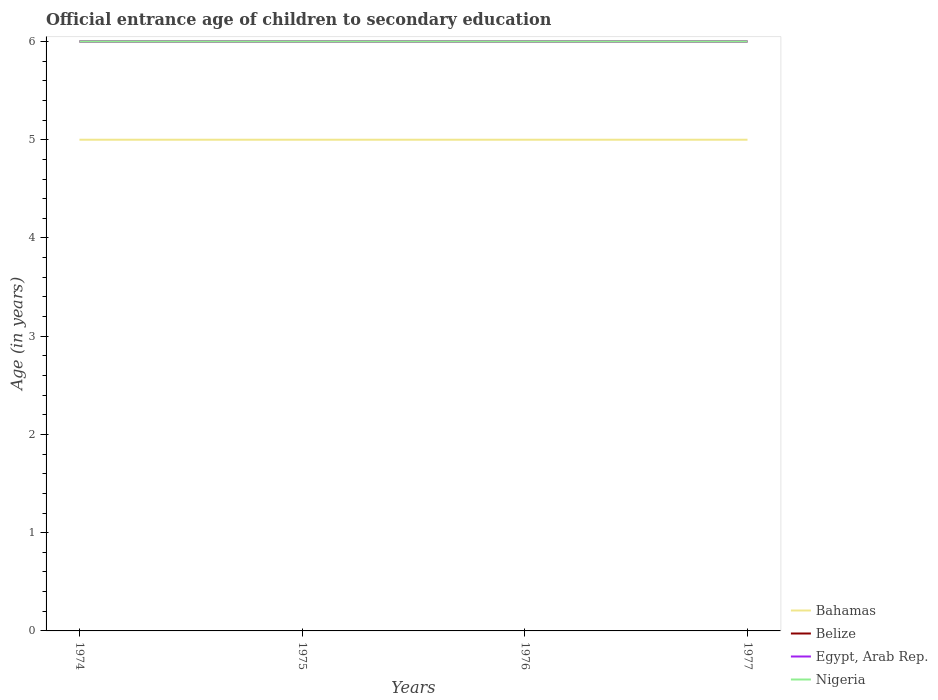How many different coloured lines are there?
Your response must be concise. 4. Does the line corresponding to Bahamas intersect with the line corresponding to Nigeria?
Offer a very short reply. No. Is the number of lines equal to the number of legend labels?
Your answer should be compact. Yes. Across all years, what is the maximum secondary school starting age of children in Bahamas?
Make the answer very short. 5. In which year was the secondary school starting age of children in Egypt, Arab Rep. maximum?
Give a very brief answer. 1974. What is the difference between the highest and the lowest secondary school starting age of children in Bahamas?
Your response must be concise. 0. Is the secondary school starting age of children in Bahamas strictly greater than the secondary school starting age of children in Egypt, Arab Rep. over the years?
Give a very brief answer. Yes. What is the difference between two consecutive major ticks on the Y-axis?
Your response must be concise. 1. Does the graph contain grids?
Your answer should be very brief. No. What is the title of the graph?
Make the answer very short. Official entrance age of children to secondary education. What is the label or title of the X-axis?
Ensure brevity in your answer.  Years. What is the label or title of the Y-axis?
Keep it short and to the point. Age (in years). What is the Age (in years) of Belize in 1974?
Ensure brevity in your answer.  6. What is the Age (in years) of Egypt, Arab Rep. in 1974?
Ensure brevity in your answer.  6. What is the Age (in years) of Egypt, Arab Rep. in 1975?
Offer a terse response. 6. What is the Age (in years) in Nigeria in 1975?
Give a very brief answer. 6. What is the Age (in years) of Bahamas in 1976?
Provide a short and direct response. 5. What is the Age (in years) in Nigeria in 1976?
Ensure brevity in your answer.  6. What is the Age (in years) of Egypt, Arab Rep. in 1977?
Give a very brief answer. 6. Across all years, what is the maximum Age (in years) of Belize?
Offer a very short reply. 6. Across all years, what is the maximum Age (in years) in Nigeria?
Offer a very short reply. 6. Across all years, what is the minimum Age (in years) in Belize?
Give a very brief answer. 6. Across all years, what is the minimum Age (in years) of Egypt, Arab Rep.?
Offer a very short reply. 6. What is the total Age (in years) of Bahamas in the graph?
Your answer should be very brief. 20. What is the total Age (in years) in Belize in the graph?
Offer a very short reply. 24. What is the total Age (in years) of Nigeria in the graph?
Keep it short and to the point. 24. What is the difference between the Age (in years) in Bahamas in 1974 and that in 1975?
Give a very brief answer. 0. What is the difference between the Age (in years) of Bahamas in 1974 and that in 1976?
Provide a succinct answer. 0. What is the difference between the Age (in years) in Belize in 1974 and that in 1976?
Ensure brevity in your answer.  0. What is the difference between the Age (in years) of Nigeria in 1974 and that in 1976?
Your response must be concise. 0. What is the difference between the Age (in years) of Belize in 1974 and that in 1977?
Keep it short and to the point. 0. What is the difference between the Age (in years) of Belize in 1975 and that in 1976?
Keep it short and to the point. 0. What is the difference between the Age (in years) of Nigeria in 1975 and that in 1976?
Provide a succinct answer. 0. What is the difference between the Age (in years) in Belize in 1975 and that in 1977?
Your answer should be very brief. 0. What is the difference between the Age (in years) of Bahamas in 1976 and that in 1977?
Your response must be concise. 0. What is the difference between the Age (in years) of Belize in 1976 and that in 1977?
Your answer should be very brief. 0. What is the difference between the Age (in years) in Bahamas in 1974 and the Age (in years) in Belize in 1975?
Offer a very short reply. -1. What is the difference between the Age (in years) in Bahamas in 1974 and the Age (in years) in Egypt, Arab Rep. in 1975?
Keep it short and to the point. -1. What is the difference between the Age (in years) in Bahamas in 1974 and the Age (in years) in Belize in 1976?
Provide a succinct answer. -1. What is the difference between the Age (in years) in Belize in 1974 and the Age (in years) in Nigeria in 1976?
Make the answer very short. 0. What is the difference between the Age (in years) in Egypt, Arab Rep. in 1974 and the Age (in years) in Nigeria in 1976?
Give a very brief answer. 0. What is the difference between the Age (in years) of Bahamas in 1974 and the Age (in years) of Belize in 1977?
Ensure brevity in your answer.  -1. What is the difference between the Age (in years) in Bahamas in 1975 and the Age (in years) in Nigeria in 1976?
Give a very brief answer. -1. What is the difference between the Age (in years) of Belize in 1975 and the Age (in years) of Nigeria in 1976?
Ensure brevity in your answer.  0. What is the difference between the Age (in years) in Bahamas in 1975 and the Age (in years) in Belize in 1977?
Your answer should be very brief. -1. What is the difference between the Age (in years) of Bahamas in 1975 and the Age (in years) of Egypt, Arab Rep. in 1977?
Your response must be concise. -1. What is the difference between the Age (in years) in Bahamas in 1975 and the Age (in years) in Nigeria in 1977?
Offer a terse response. -1. What is the difference between the Age (in years) in Belize in 1975 and the Age (in years) in Egypt, Arab Rep. in 1977?
Keep it short and to the point. 0. What is the difference between the Age (in years) of Egypt, Arab Rep. in 1975 and the Age (in years) of Nigeria in 1977?
Provide a short and direct response. 0. What is the difference between the Age (in years) in Bahamas in 1976 and the Age (in years) in Nigeria in 1977?
Give a very brief answer. -1. What is the difference between the Age (in years) of Belize in 1976 and the Age (in years) of Egypt, Arab Rep. in 1977?
Your answer should be compact. 0. What is the difference between the Age (in years) of Egypt, Arab Rep. in 1976 and the Age (in years) of Nigeria in 1977?
Your response must be concise. 0. What is the average Age (in years) in Bahamas per year?
Your answer should be very brief. 5. What is the average Age (in years) of Belize per year?
Make the answer very short. 6. In the year 1974, what is the difference between the Age (in years) of Bahamas and Age (in years) of Belize?
Provide a succinct answer. -1. In the year 1974, what is the difference between the Age (in years) in Belize and Age (in years) in Egypt, Arab Rep.?
Ensure brevity in your answer.  0. In the year 1974, what is the difference between the Age (in years) in Egypt, Arab Rep. and Age (in years) in Nigeria?
Offer a very short reply. 0. In the year 1975, what is the difference between the Age (in years) in Bahamas and Age (in years) in Belize?
Offer a terse response. -1. In the year 1975, what is the difference between the Age (in years) of Egypt, Arab Rep. and Age (in years) of Nigeria?
Offer a very short reply. 0. In the year 1976, what is the difference between the Age (in years) of Bahamas and Age (in years) of Belize?
Your response must be concise. -1. In the year 1976, what is the difference between the Age (in years) of Bahamas and Age (in years) of Egypt, Arab Rep.?
Ensure brevity in your answer.  -1. In the year 1976, what is the difference between the Age (in years) of Bahamas and Age (in years) of Nigeria?
Your response must be concise. -1. In the year 1976, what is the difference between the Age (in years) of Belize and Age (in years) of Nigeria?
Offer a very short reply. 0. In the year 1977, what is the difference between the Age (in years) in Bahamas and Age (in years) in Nigeria?
Your answer should be very brief. -1. In the year 1977, what is the difference between the Age (in years) in Belize and Age (in years) in Egypt, Arab Rep.?
Keep it short and to the point. 0. In the year 1977, what is the difference between the Age (in years) of Belize and Age (in years) of Nigeria?
Your answer should be very brief. 0. What is the ratio of the Age (in years) in Bahamas in 1974 to that in 1975?
Ensure brevity in your answer.  1. What is the ratio of the Age (in years) of Belize in 1974 to that in 1975?
Make the answer very short. 1. What is the ratio of the Age (in years) in Belize in 1974 to that in 1976?
Keep it short and to the point. 1. What is the ratio of the Age (in years) in Nigeria in 1974 to that in 1976?
Give a very brief answer. 1. What is the ratio of the Age (in years) in Belize in 1974 to that in 1977?
Your answer should be very brief. 1. What is the ratio of the Age (in years) of Nigeria in 1975 to that in 1976?
Provide a short and direct response. 1. What is the ratio of the Age (in years) in Bahamas in 1975 to that in 1977?
Your answer should be compact. 1. What is the ratio of the Age (in years) of Belize in 1976 to that in 1977?
Your response must be concise. 1. What is the difference between the highest and the second highest Age (in years) of Bahamas?
Offer a very short reply. 0. What is the difference between the highest and the second highest Age (in years) in Belize?
Provide a succinct answer. 0. What is the difference between the highest and the second highest Age (in years) in Nigeria?
Make the answer very short. 0. What is the difference between the highest and the lowest Age (in years) in Bahamas?
Your answer should be very brief. 0. What is the difference between the highest and the lowest Age (in years) of Egypt, Arab Rep.?
Give a very brief answer. 0. 